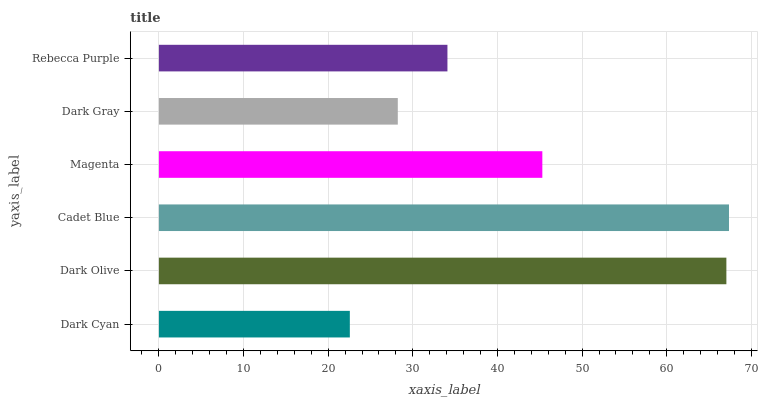Is Dark Cyan the minimum?
Answer yes or no. Yes. Is Cadet Blue the maximum?
Answer yes or no. Yes. Is Dark Olive the minimum?
Answer yes or no. No. Is Dark Olive the maximum?
Answer yes or no. No. Is Dark Olive greater than Dark Cyan?
Answer yes or no. Yes. Is Dark Cyan less than Dark Olive?
Answer yes or no. Yes. Is Dark Cyan greater than Dark Olive?
Answer yes or no. No. Is Dark Olive less than Dark Cyan?
Answer yes or no. No. Is Magenta the high median?
Answer yes or no. Yes. Is Rebecca Purple the low median?
Answer yes or no. Yes. Is Dark Gray the high median?
Answer yes or no. No. Is Magenta the low median?
Answer yes or no. No. 